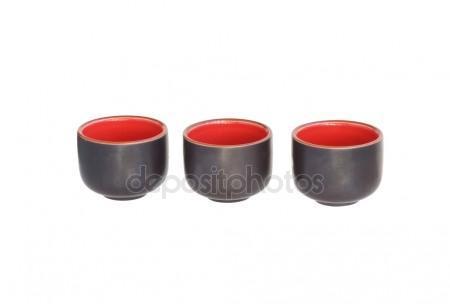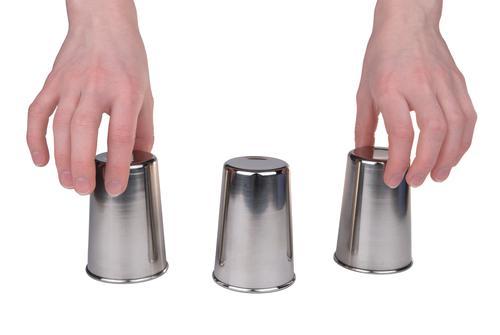The first image is the image on the left, the second image is the image on the right. Evaluate the accuracy of this statement regarding the images: "An image shows a row of three cups that are upside-down.". Is it true? Answer yes or no. Yes. 